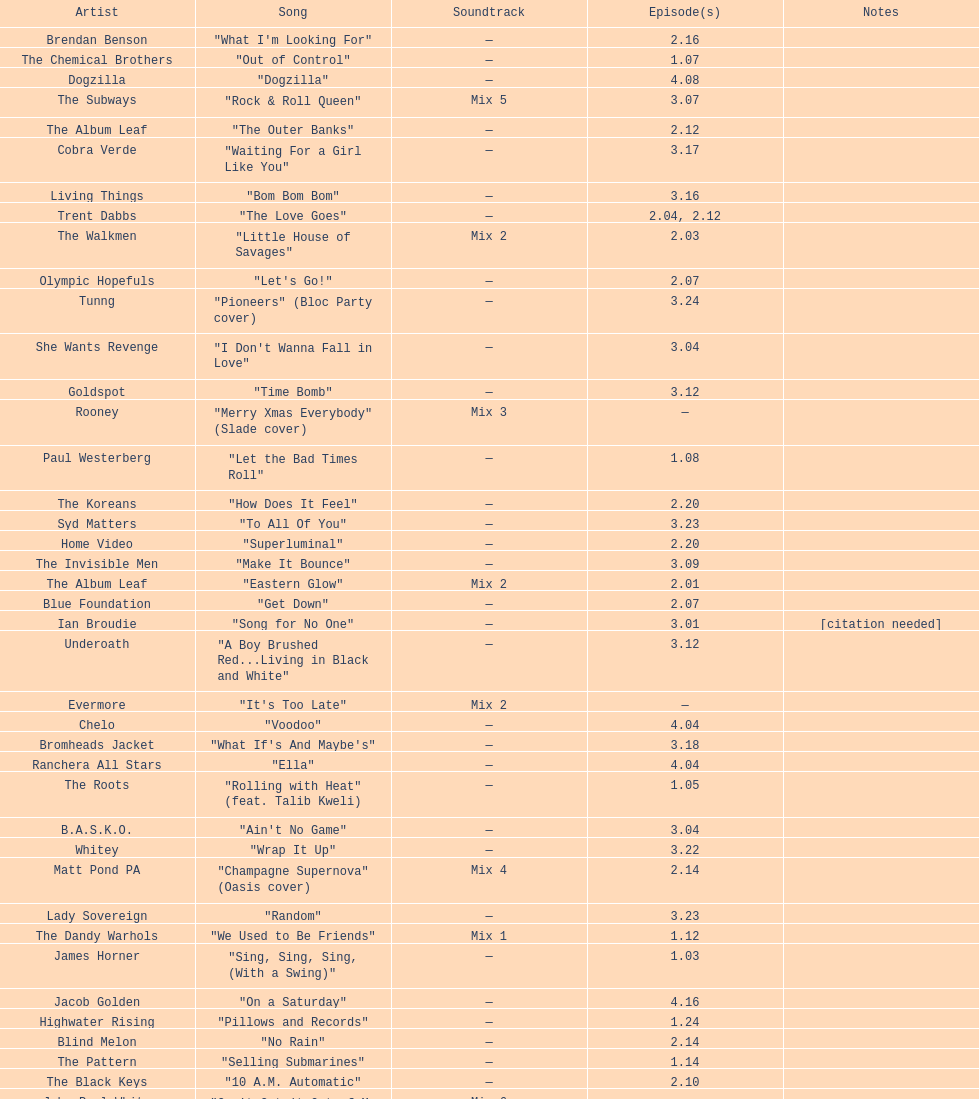What artist has more music appear in the show, daft punk or franz ferdinand? Franz Ferdinand. 